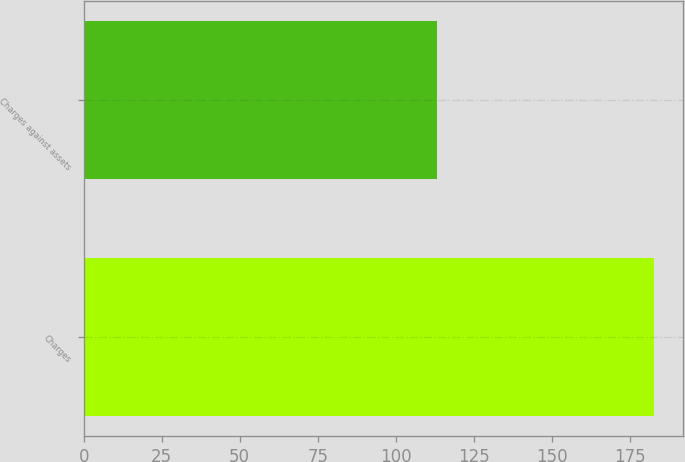Convert chart to OTSL. <chart><loc_0><loc_0><loc_500><loc_500><bar_chart><fcel>Charges<fcel>Charges against assets<nl><fcel>182.8<fcel>113.3<nl></chart> 